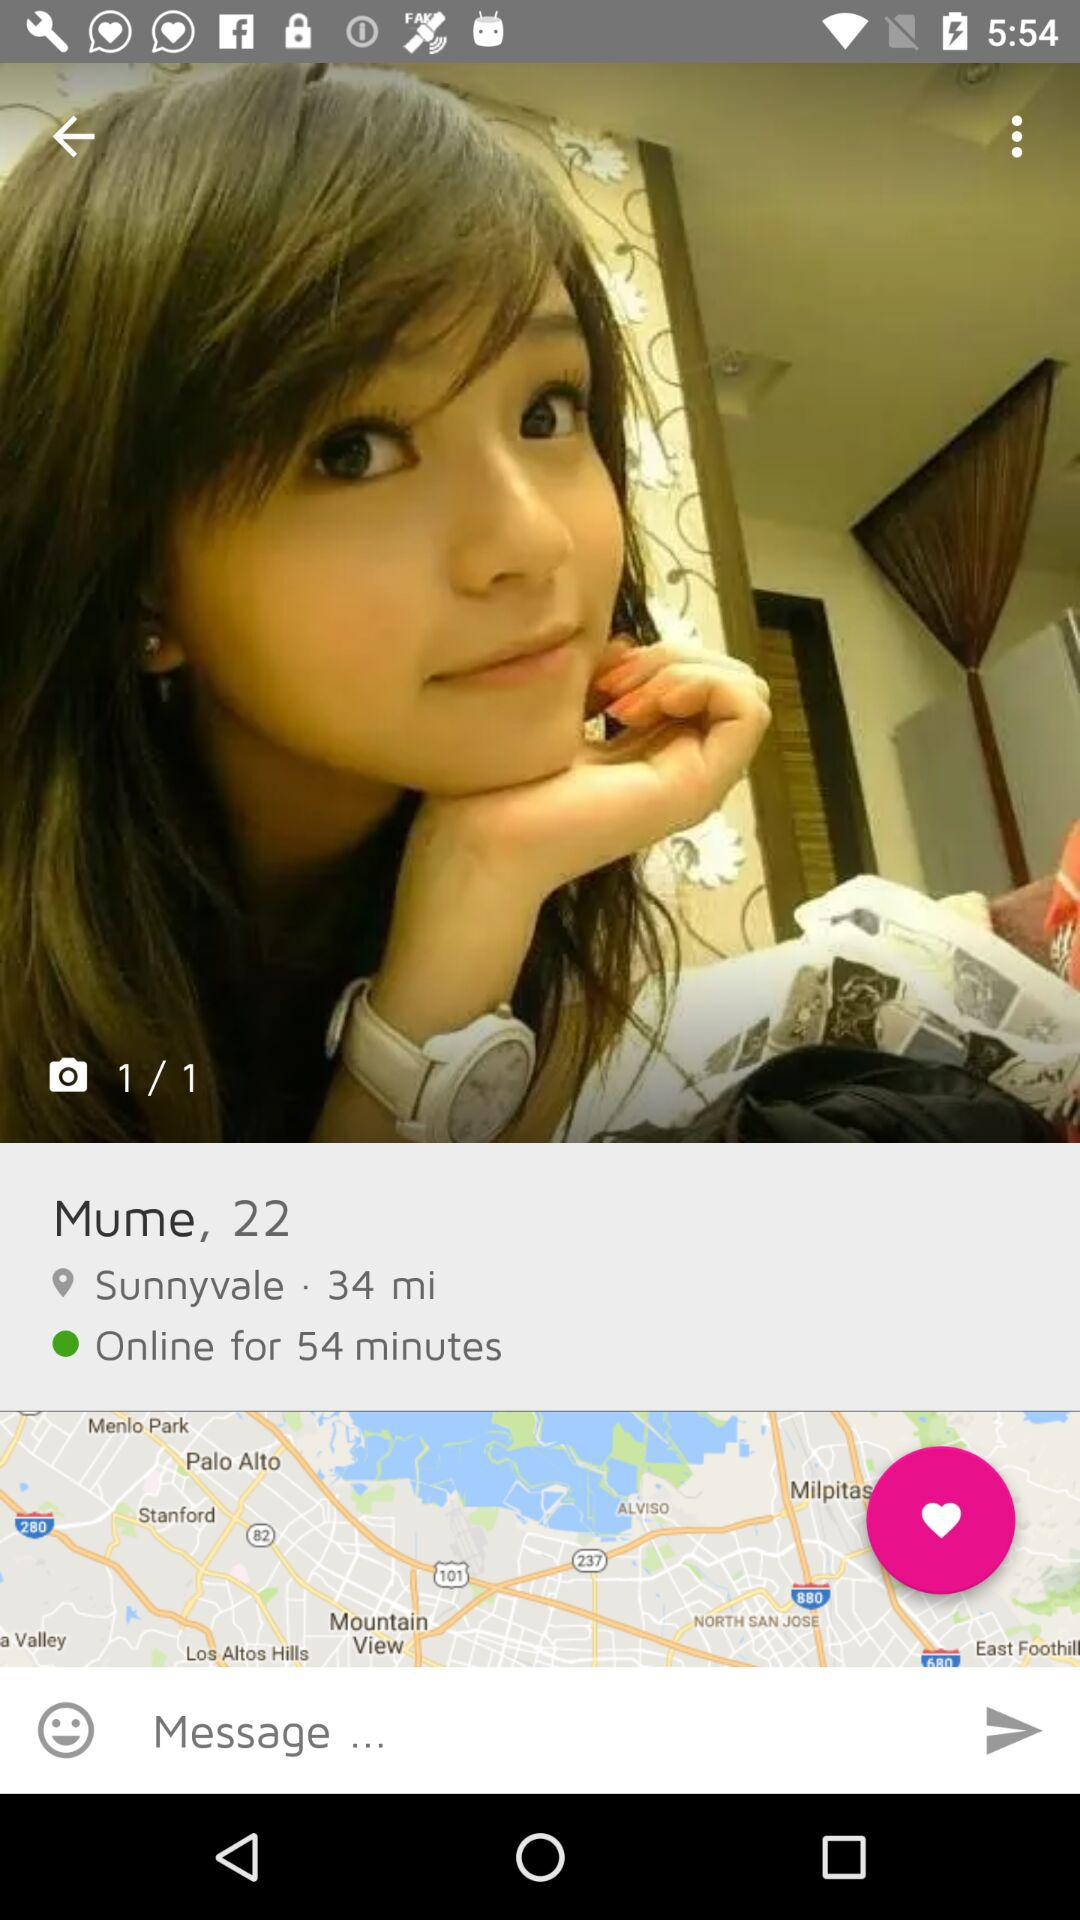How many more miles away is Mume than the user is?
Answer the question using a single word or phrase. 34 